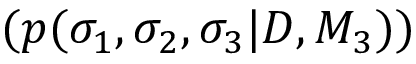<formula> <loc_0><loc_0><loc_500><loc_500>( p ( \sigma _ { 1 } , \sigma _ { 2 } , \sigma _ { 3 } | D , M _ { 3 } ) )</formula> 